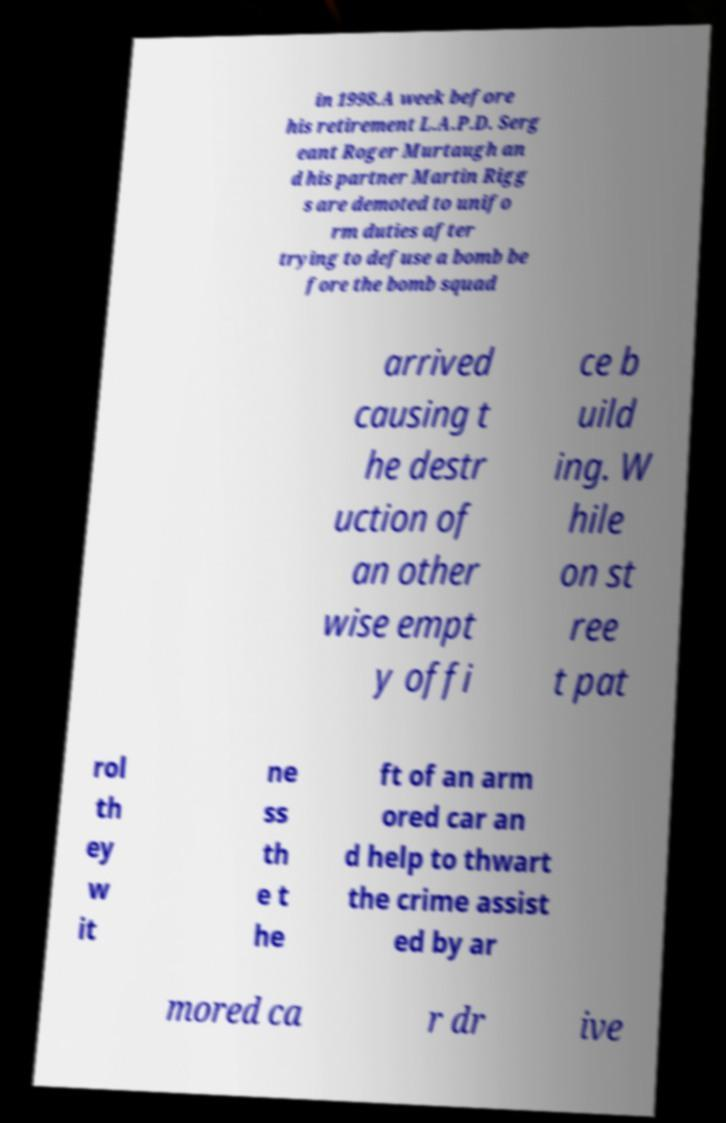There's text embedded in this image that I need extracted. Can you transcribe it verbatim? in 1998.A week before his retirement L.A.P.D. Serg eant Roger Murtaugh an d his partner Martin Rigg s are demoted to unifo rm duties after trying to defuse a bomb be fore the bomb squad arrived causing t he destr uction of an other wise empt y offi ce b uild ing. W hile on st ree t pat rol th ey w it ne ss th e t he ft of an arm ored car an d help to thwart the crime assist ed by ar mored ca r dr ive 